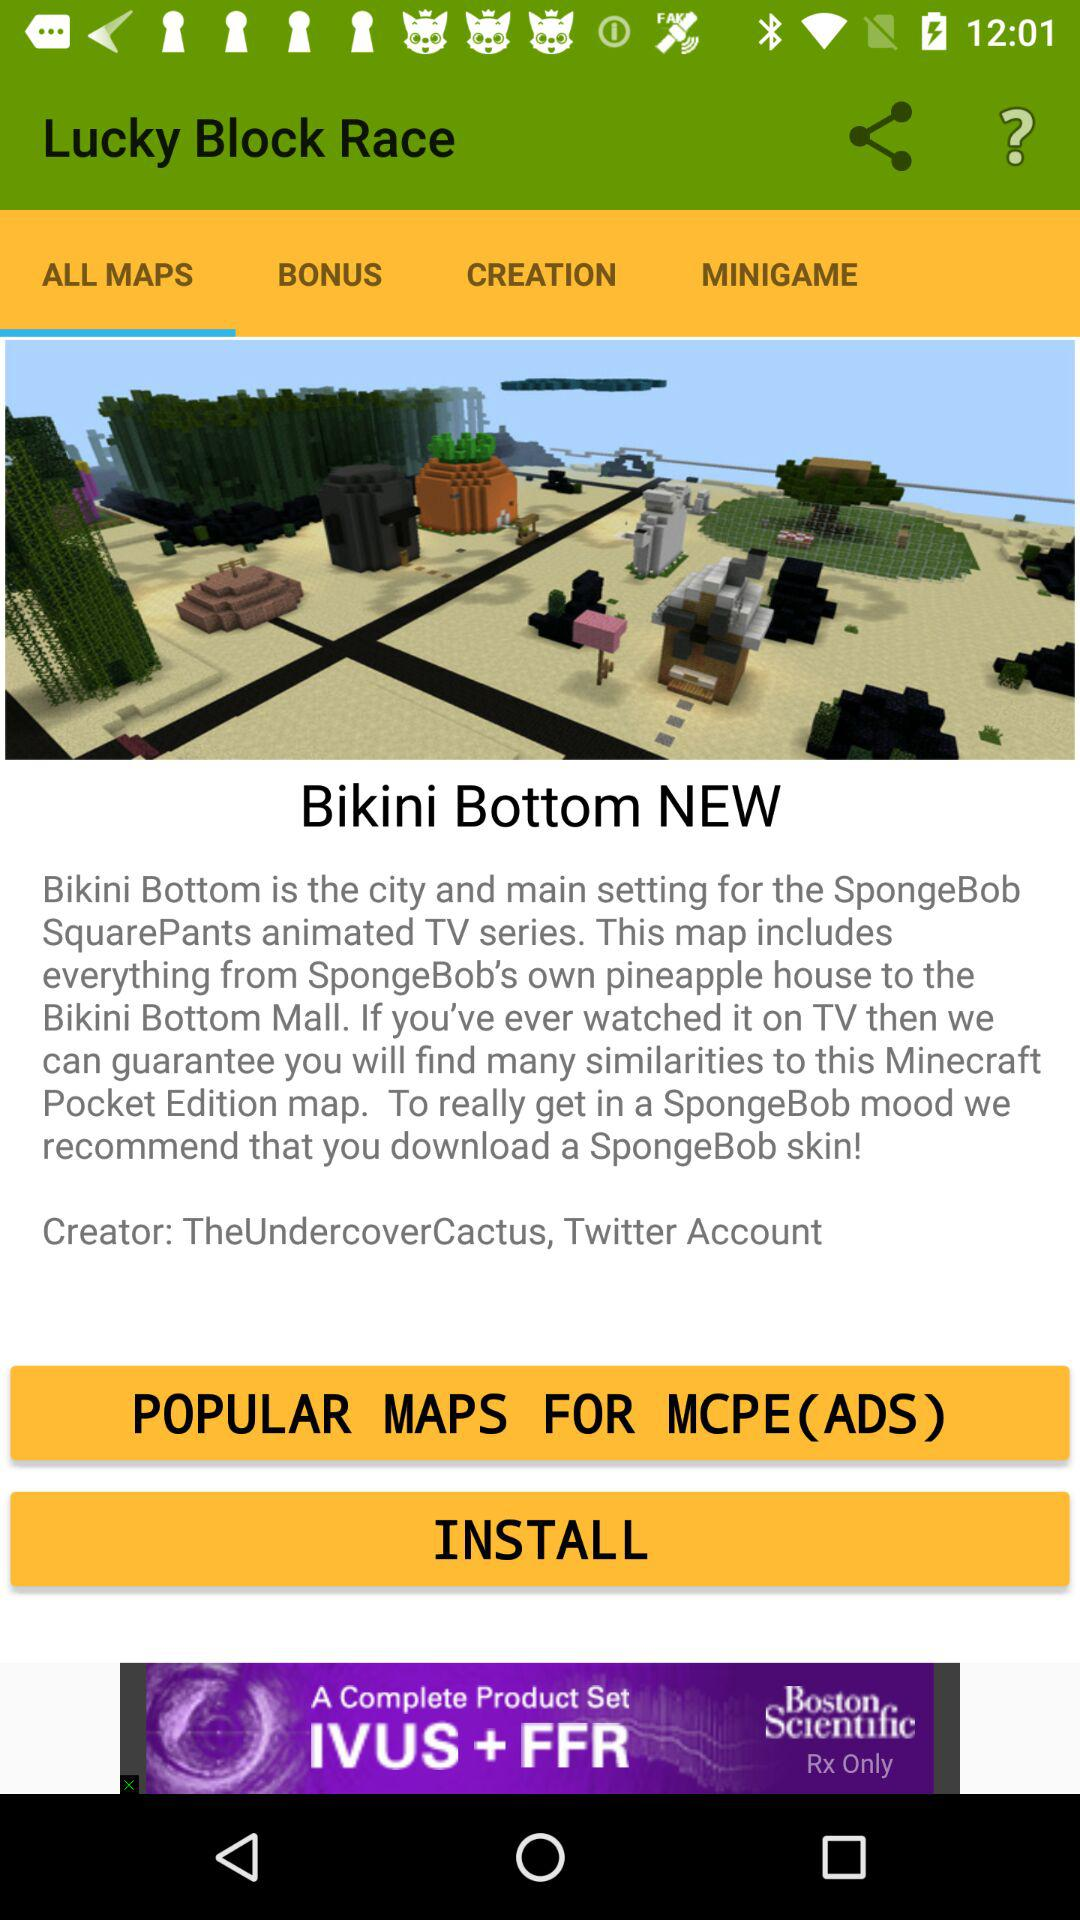Which tab is currently selected? The currently selected tab is "ALL MAPS". 